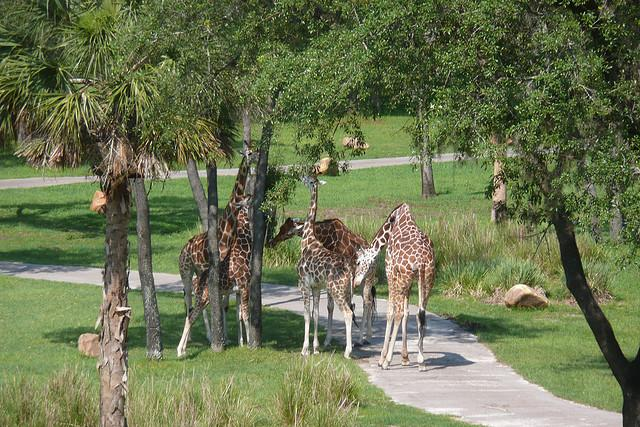Where are these animals most likely to be found in their natural habitat? africa 